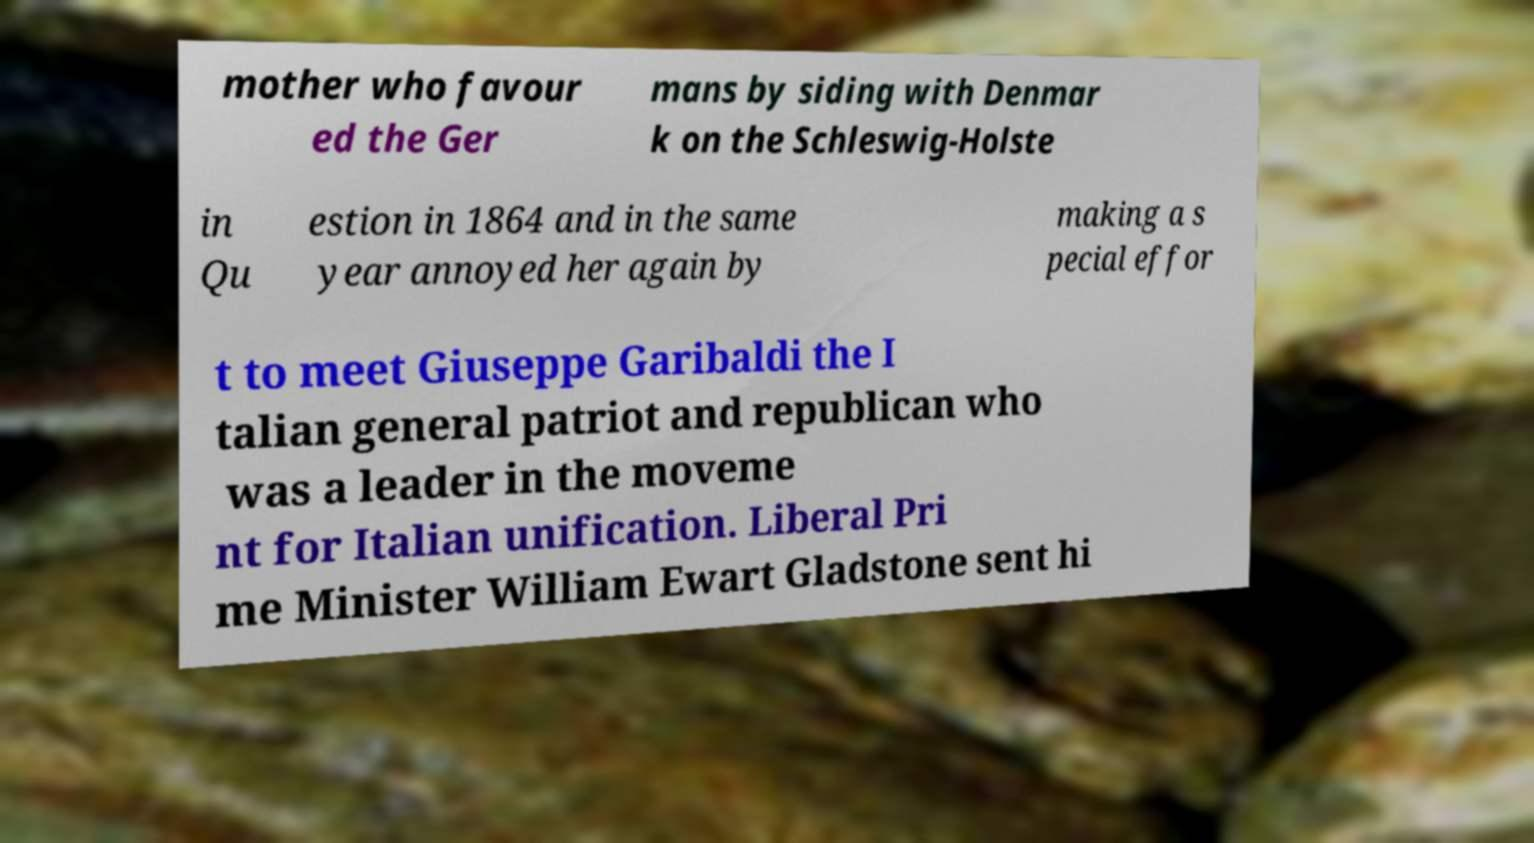Can you accurately transcribe the text from the provided image for me? mother who favour ed the Ger mans by siding with Denmar k on the Schleswig-Holste in Qu estion in 1864 and in the same year annoyed her again by making a s pecial effor t to meet Giuseppe Garibaldi the I talian general patriot and republican who was a leader in the moveme nt for Italian unification. Liberal Pri me Minister William Ewart Gladstone sent hi 